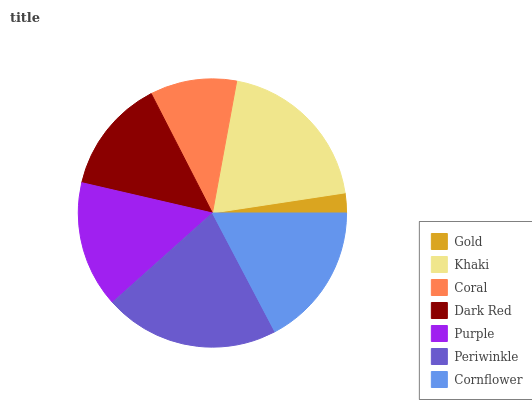Is Gold the minimum?
Answer yes or no. Yes. Is Periwinkle the maximum?
Answer yes or no. Yes. Is Khaki the minimum?
Answer yes or no. No. Is Khaki the maximum?
Answer yes or no. No. Is Khaki greater than Gold?
Answer yes or no. Yes. Is Gold less than Khaki?
Answer yes or no. Yes. Is Gold greater than Khaki?
Answer yes or no. No. Is Khaki less than Gold?
Answer yes or no. No. Is Purple the high median?
Answer yes or no. Yes. Is Purple the low median?
Answer yes or no. Yes. Is Khaki the high median?
Answer yes or no. No. Is Gold the low median?
Answer yes or no. No. 